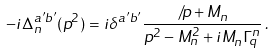<formula> <loc_0><loc_0><loc_500><loc_500>- i \Delta _ { n } ^ { a ^ { \prime } b ^ { \prime } } ( p ^ { 2 } ) = i \delta ^ { a ^ { \prime } b ^ { \prime } } \frac { \not \, p + M _ { n } } { p ^ { 2 } - M _ { n } ^ { 2 } + i M _ { n } \Gamma _ { q } ^ { n } } \, .</formula> 